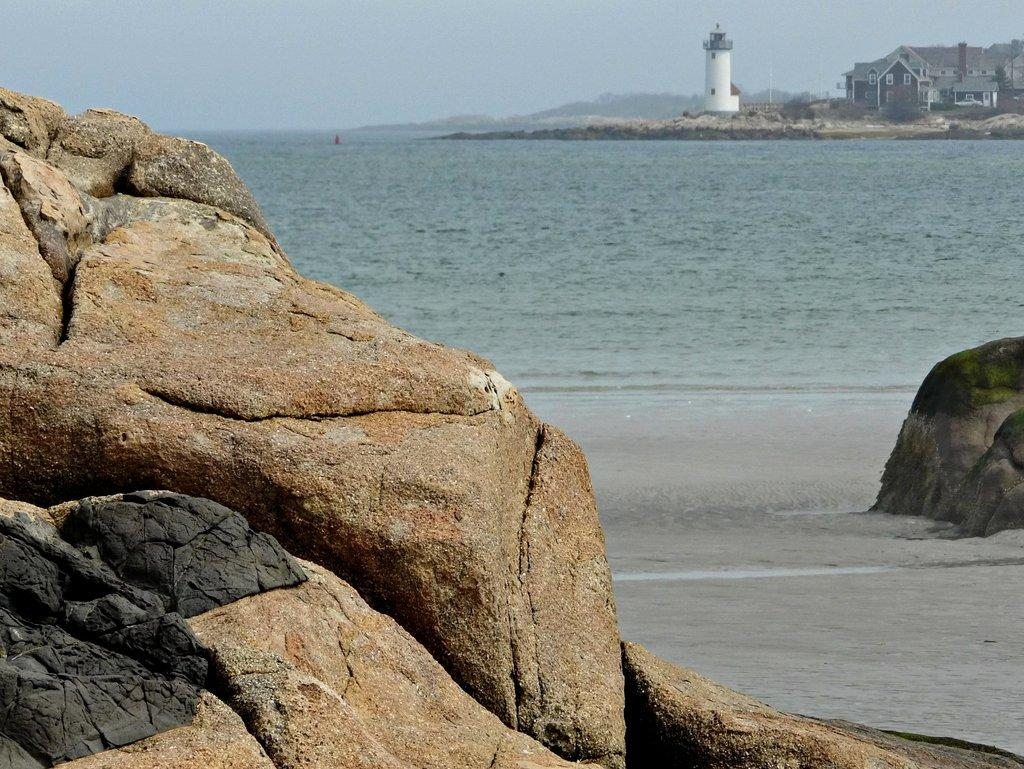What type of natural elements can be seen in the image? There are rocks and water in the image. What man-made structure is present in the image? There is a tower in the image. What type of residential buildings are visible in the image? There are houses with windows in the image. What is visible in the background of the image? The sky is visible in the background of the image. Can you tell me how many firemen are visible in the image? There are no firemen present in the image. What type of wire is being used to support the houses in the image? There is no wire visible in the image; the houses are supported by their foundations. 